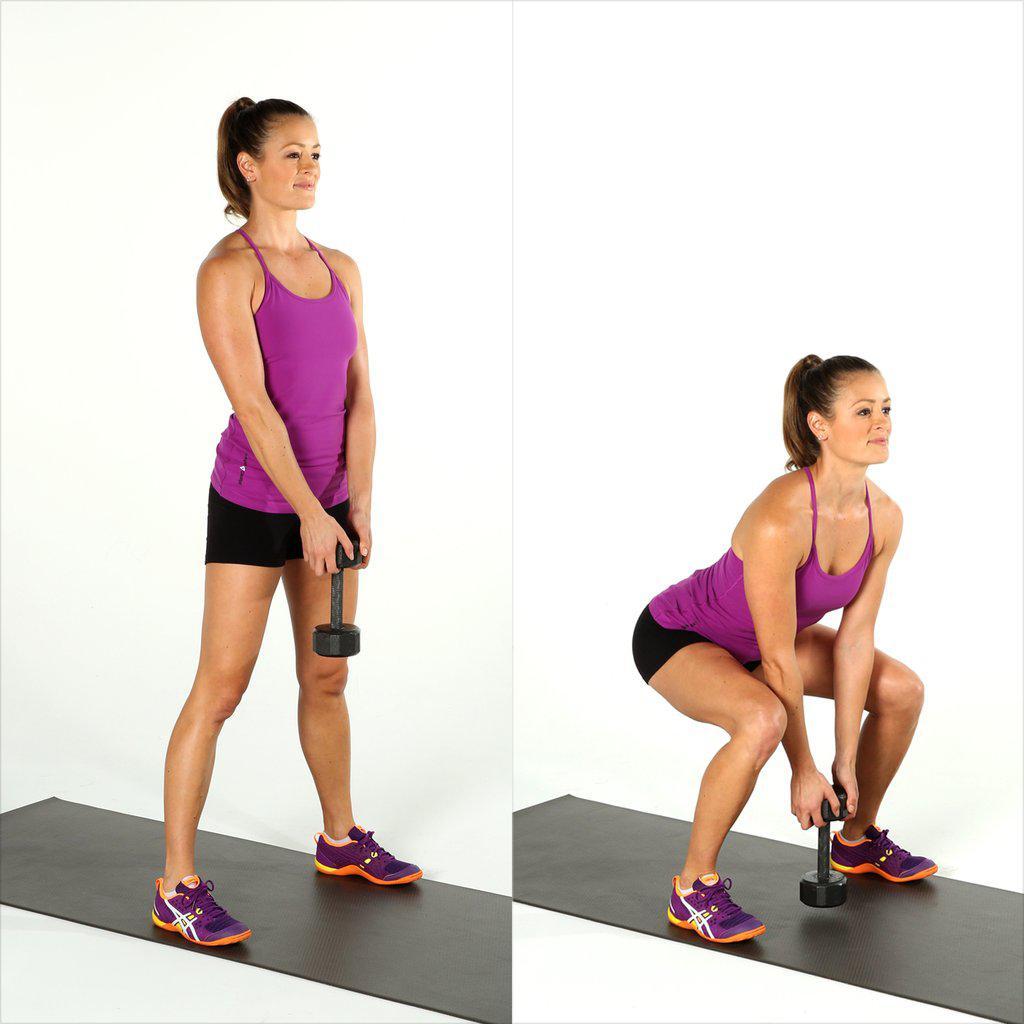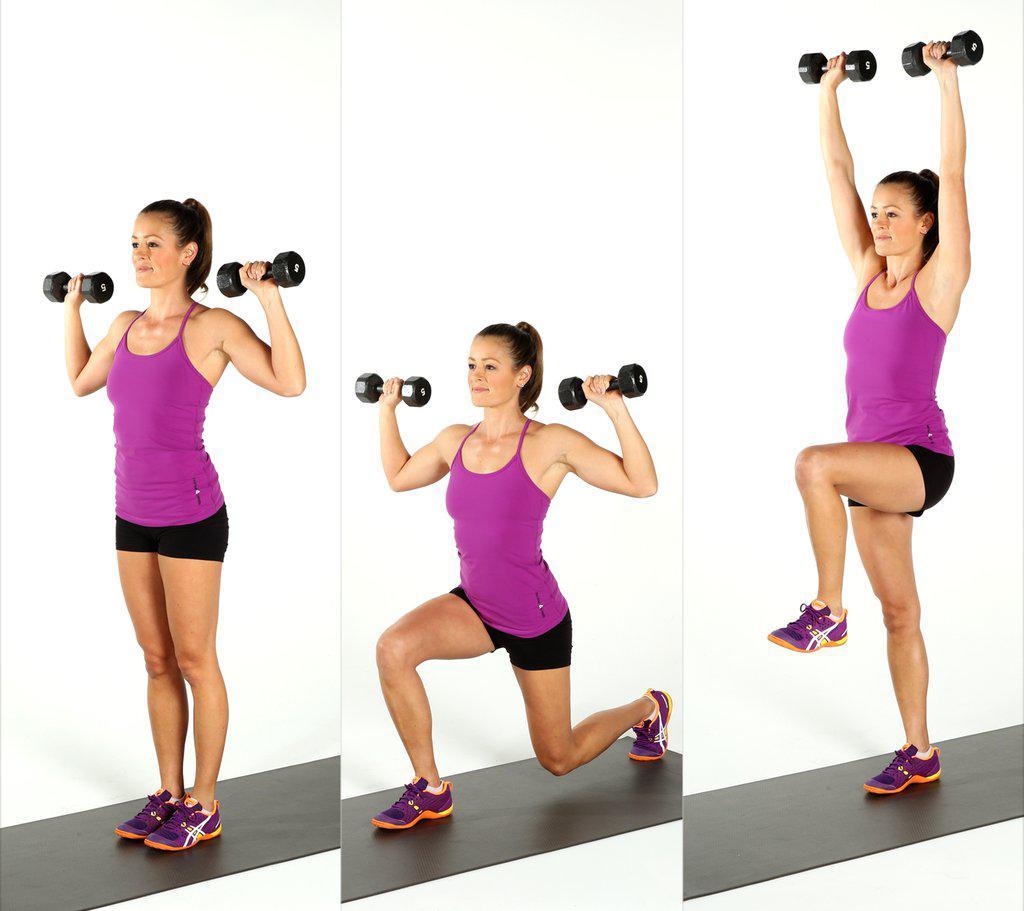The first image is the image on the left, the second image is the image on the right. Evaluate the accuracy of this statement regarding the images: "The left and right image contains the same number of women using weights.". Is it true? Answer yes or no. No. The first image is the image on the left, the second image is the image on the right. For the images displayed, is the sentence "Each image shows a woman demonstrating at least two different positions in a dumbbell workout." factually correct? Answer yes or no. Yes. 